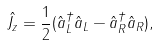<formula> <loc_0><loc_0><loc_500><loc_500>\hat { J _ { z } } = \frac { 1 } { 2 } ( \hat { a } _ { L } ^ { \dag } \hat { a } _ { L } - \hat { a } _ { R } ^ { \dag } \hat { a } _ { R } ) ,</formula> 